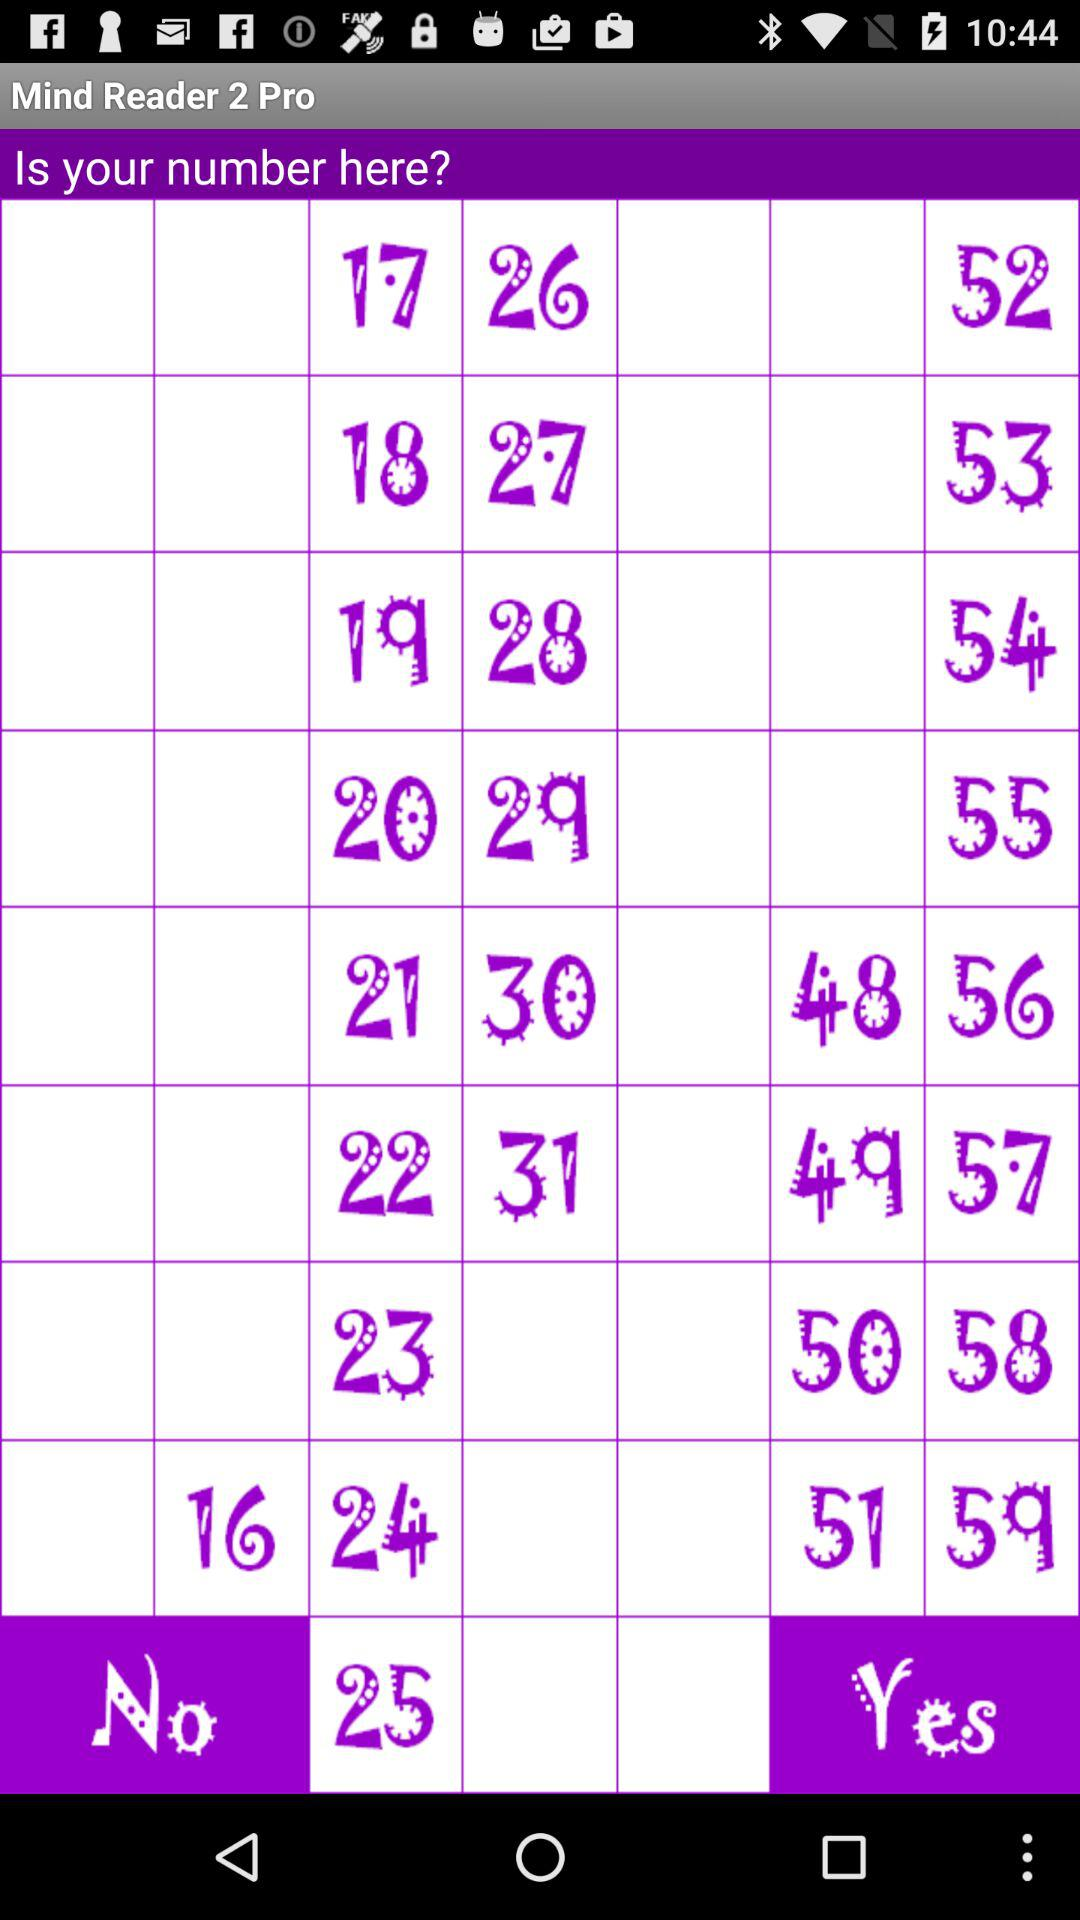What is the application Name? The application name is "Mind Reader 2 Pro". 